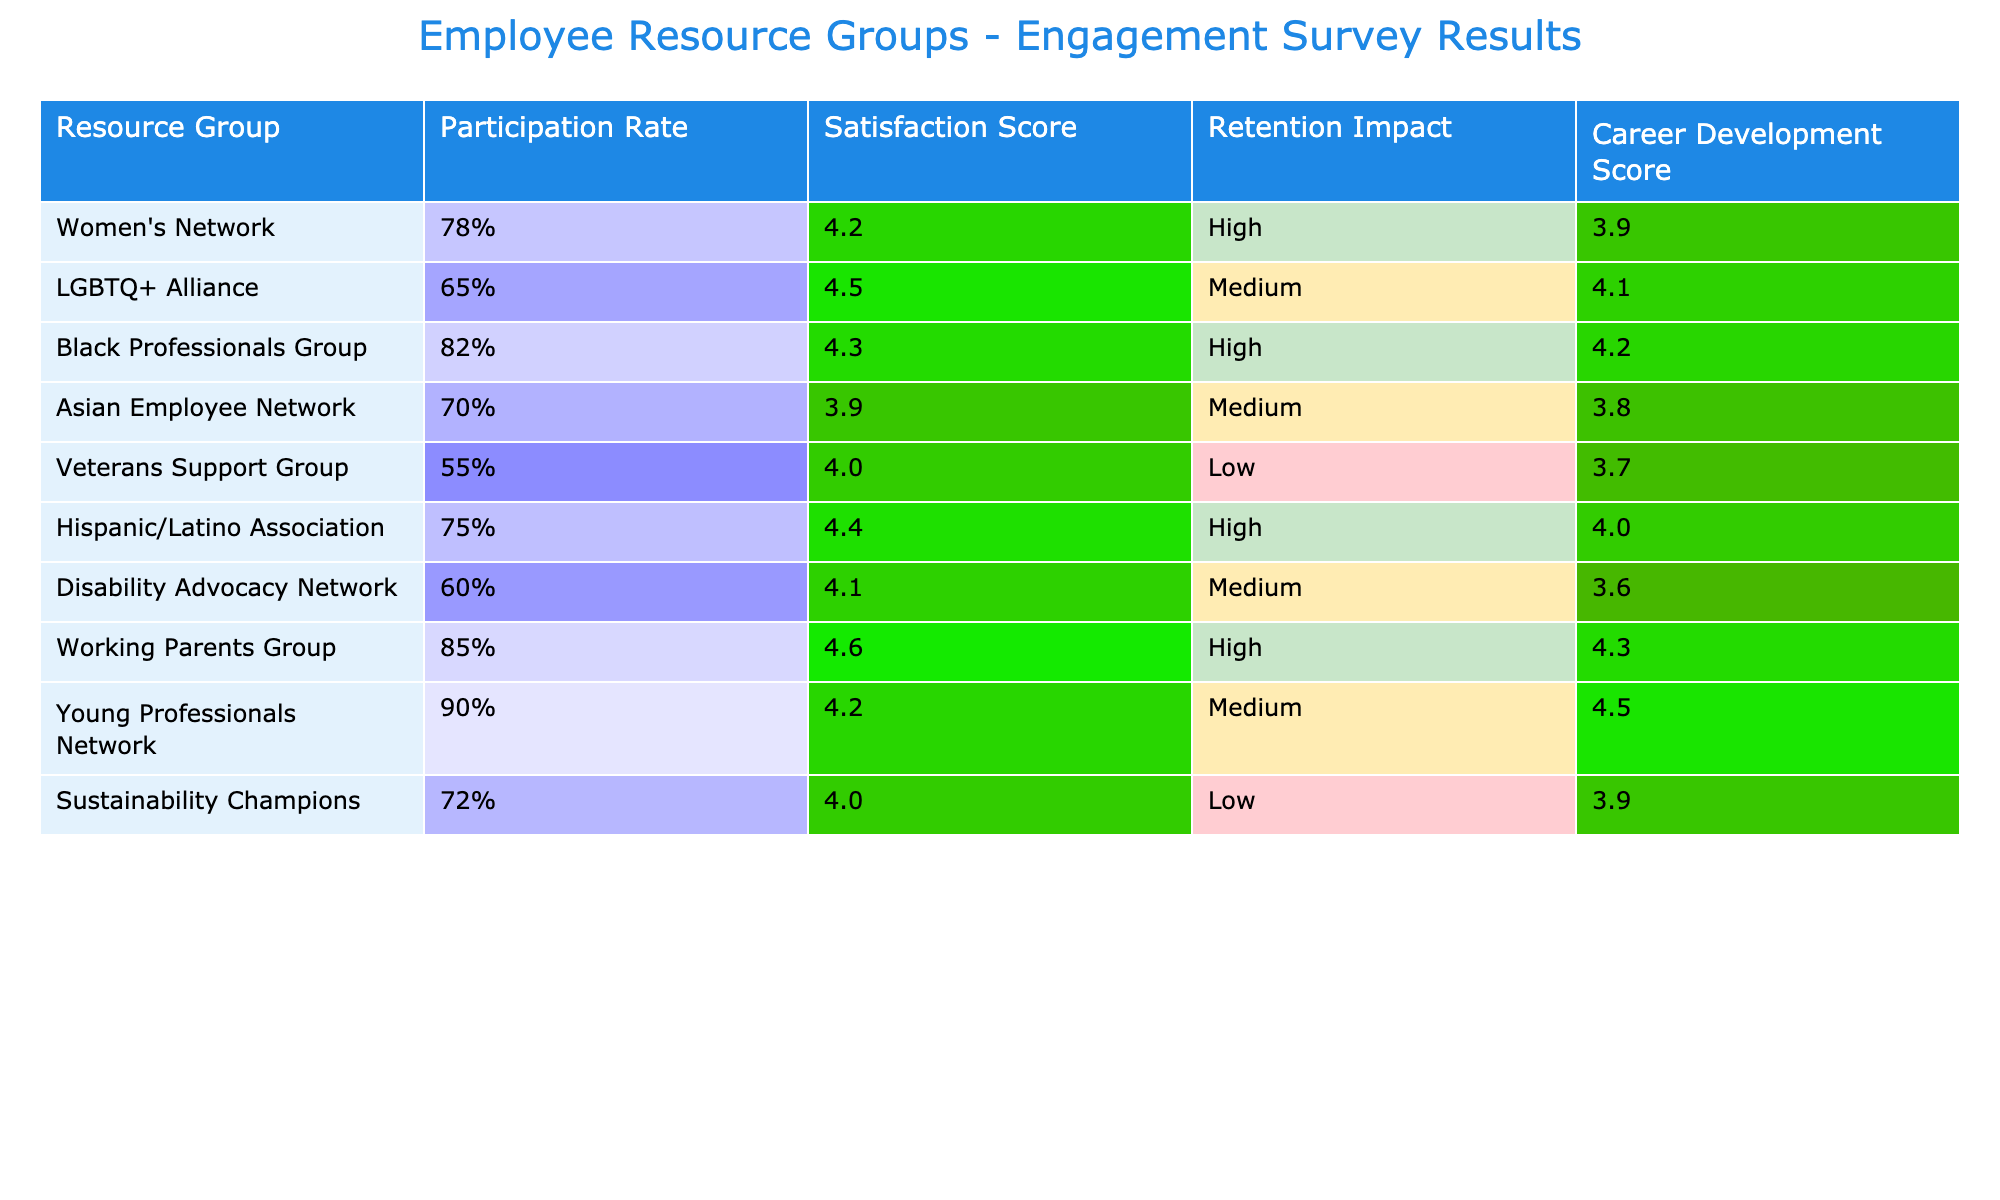What is the satisfaction score for the LGBTQ+ Alliance? From the table, we can find the row corresponding to the LGBTQ+ Alliance, and the satisfaction score listed in that row is 4.5.
Answer: 4.5 Which resource group has the highest retention impact? Looking through the retention impact column, I see that the resource groups with 'High' retention impact are: Women’s Network, Black Professionals Group, Hispanic/Latino Association, and Working Parents Group. There are multiple, which means the answer is not one group but several.
Answer: Multiple groups What is the average career development score for all the resource groups? To find the average, we sum the career development scores: (3.9 + 4.1 + 4.2 + 3.8 + 3.7 + 4.0 + 3.6 + 4.3 + 4.5) = 36.1. There are 9 groups, so the average is 36.1/9 = 4.01.
Answer: 4.01 Did the Working Parents Group have a higher participation rate than the Veterans Support Group? The participation rate for the Working Parents Group is 85% and for the Veterans Support Group it is 55%. Since 85% is greater than 55%, the answer is yes.
Answer: Yes What is the difference between the average satisfaction score of groups with 'High' retention impact and those with 'Low' retention impact? The groups with 'High' retention impact are: Women’s Network, Black Professionals Group, Hispanic/Latino Association, and Working Parents Group with scores of 4.2, 4.3, 4.4, and 4.6, respectively. Their average is (4.2 + 4.3 + 4.4 + 4.6) = 17.5 / 4 = 4.375. The 'Low' retention impact groups are: Veterans Support Group (4.0) and Sustainability Champions (4.0) with average (4.0 + 4.0) = 8.0 / 2 = 4.0. The difference is 4.375 - 4.0 = 0.375.
Answer: 0.375 